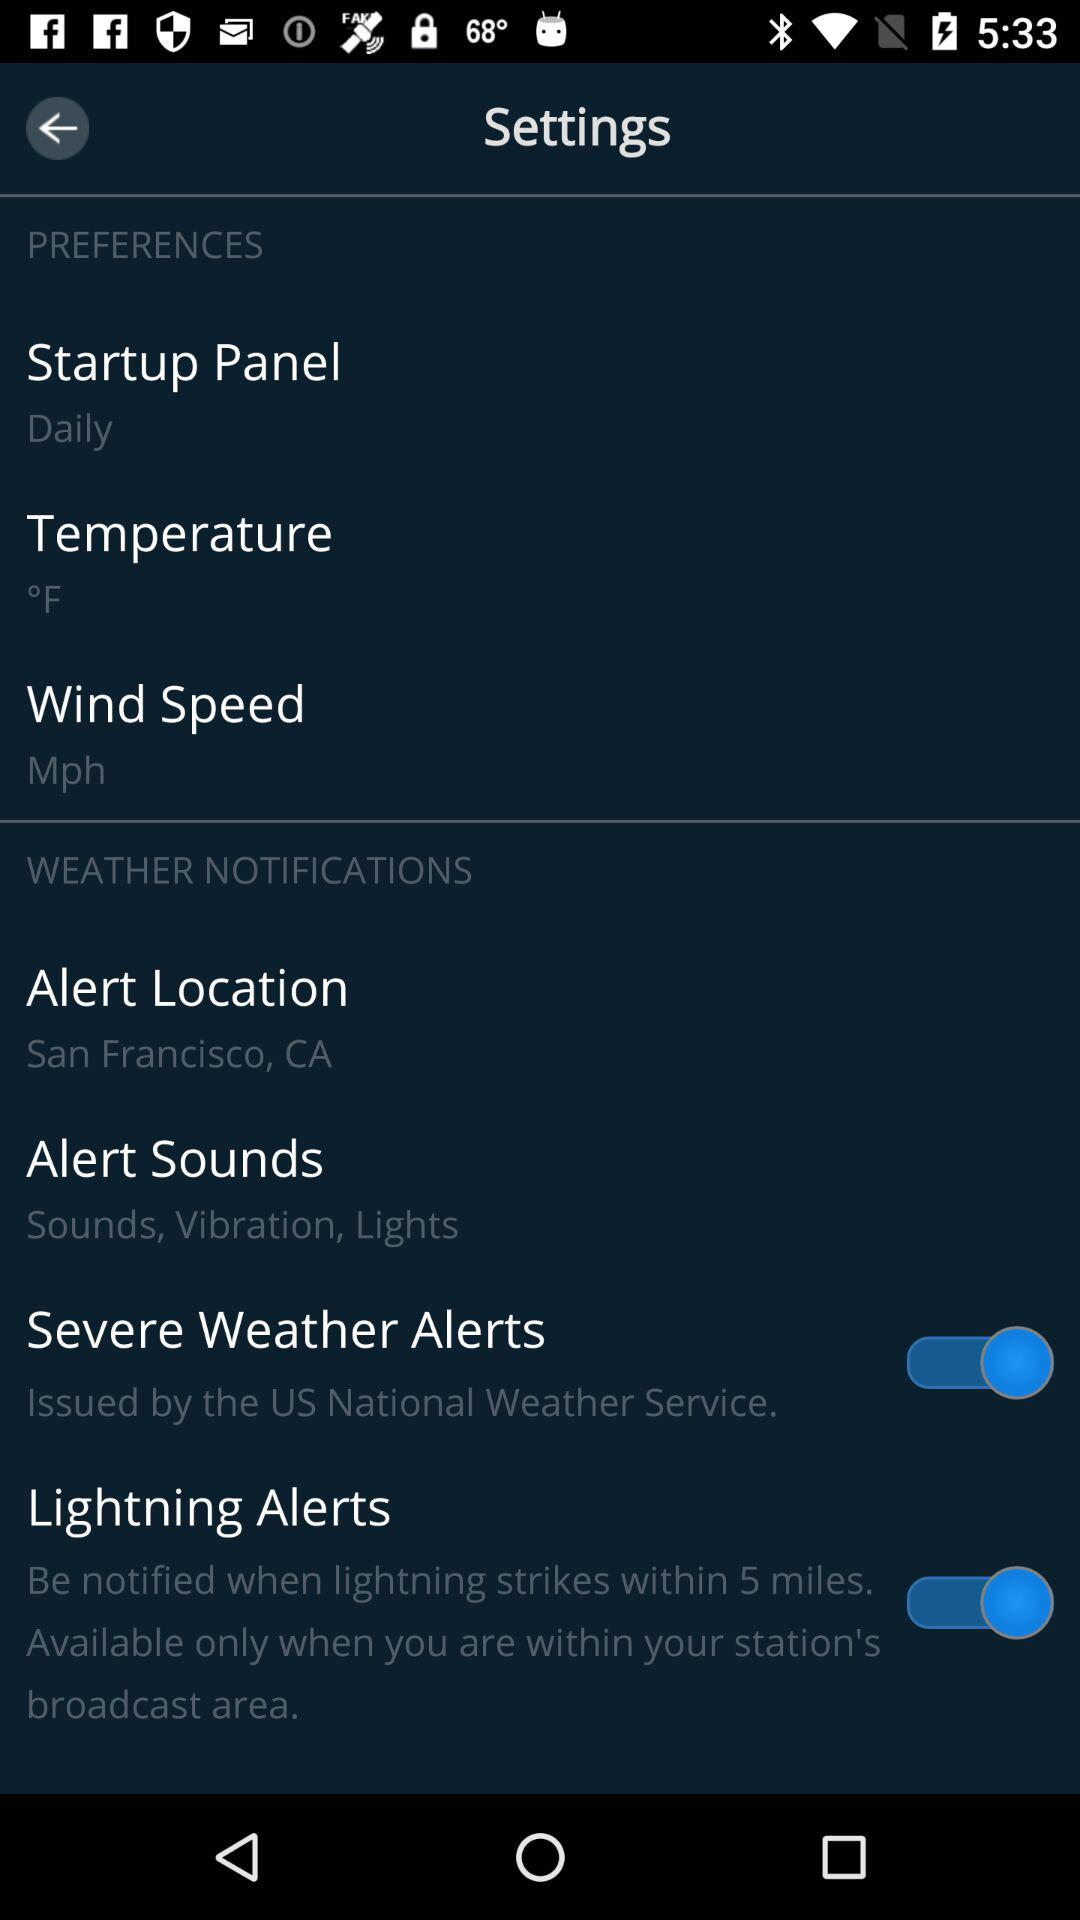How many items have a switch in the Weather Notifications section?
Answer the question using a single word or phrase. 2 